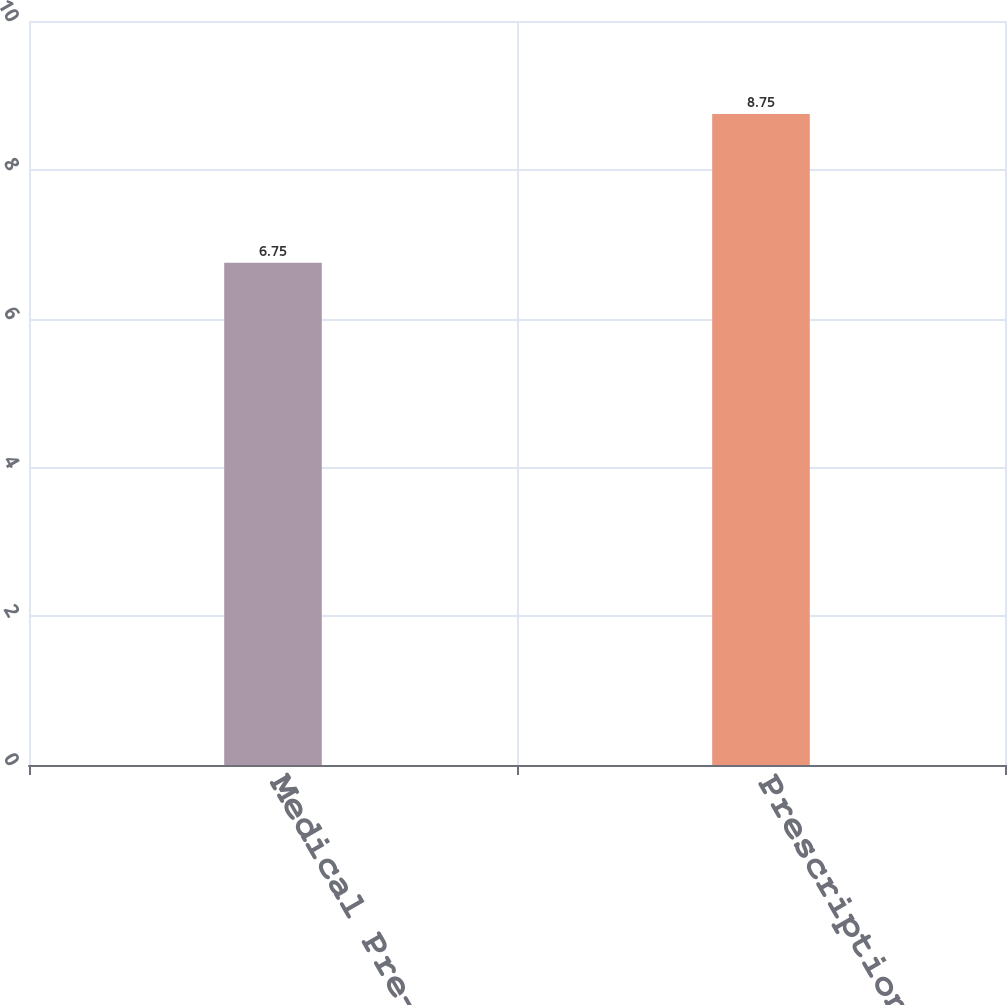Convert chart to OTSL. <chart><loc_0><loc_0><loc_500><loc_500><bar_chart><fcel>Medical Pre-65<fcel>Prescription drugs<nl><fcel>6.75<fcel>8.75<nl></chart> 